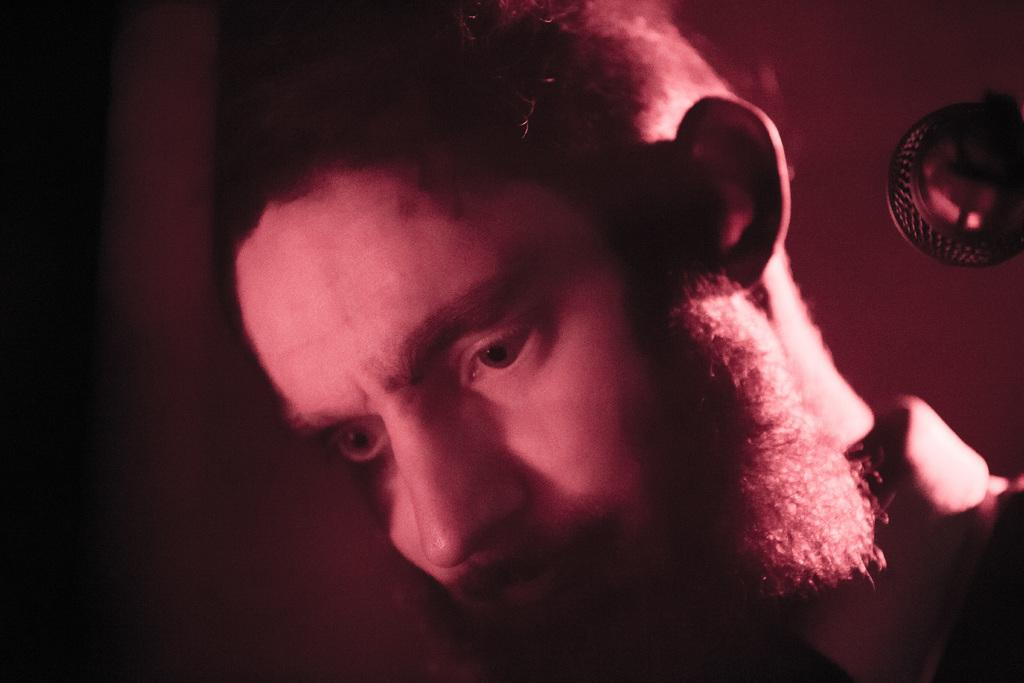Who or what is present in the image? There is a person in the image. What is the person doing in the image? The person is looking down. Can you describe the object on the wall behind the person? There is a metal object on the wall behind the person. What is the color or lighting condition of the background in the image? The background of the image is dark. What type of fog can be seen in the image? There is no fog present in the image; it features a person looking down with a metal object on the wall behind them, and the background is dark. 